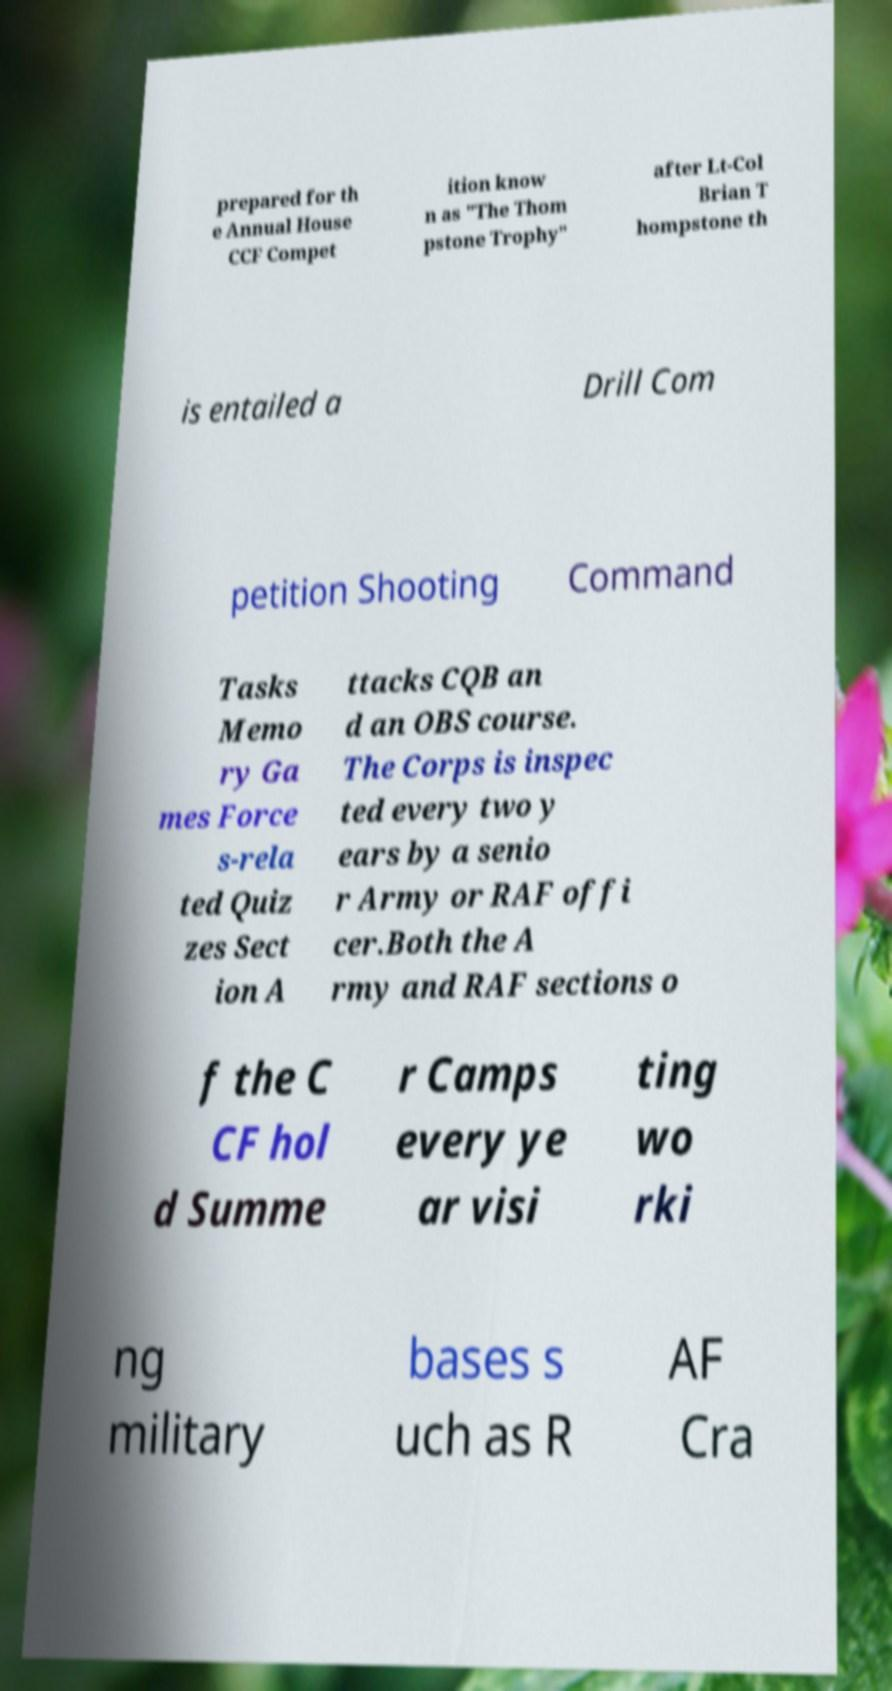Could you extract and type out the text from this image? prepared for th e Annual House CCF Compet ition know n as "The Thom pstone Trophy" after Lt-Col Brian T hompstone th is entailed a Drill Com petition Shooting Command Tasks Memo ry Ga mes Force s-rela ted Quiz zes Sect ion A ttacks CQB an d an OBS course. The Corps is inspec ted every two y ears by a senio r Army or RAF offi cer.Both the A rmy and RAF sections o f the C CF hol d Summe r Camps every ye ar visi ting wo rki ng military bases s uch as R AF Cra 